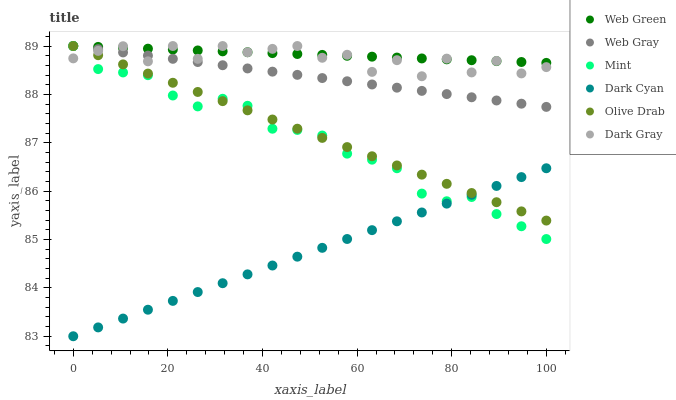Does Dark Cyan have the minimum area under the curve?
Answer yes or no. Yes. Does Web Green have the maximum area under the curve?
Answer yes or no. Yes. Does Dark Gray have the minimum area under the curve?
Answer yes or no. No. Does Dark Gray have the maximum area under the curve?
Answer yes or no. No. Is Web Green the smoothest?
Answer yes or no. Yes. Is Dark Gray the roughest?
Answer yes or no. Yes. Is Dark Gray the smoothest?
Answer yes or no. No. Is Web Green the roughest?
Answer yes or no. No. Does Dark Cyan have the lowest value?
Answer yes or no. Yes. Does Dark Gray have the lowest value?
Answer yes or no. No. Does Olive Drab have the highest value?
Answer yes or no. Yes. Does Dark Cyan have the highest value?
Answer yes or no. No. Is Dark Cyan less than Web Green?
Answer yes or no. Yes. Is Dark Gray greater than Dark Cyan?
Answer yes or no. Yes. Does Dark Cyan intersect Olive Drab?
Answer yes or no. Yes. Is Dark Cyan less than Olive Drab?
Answer yes or no. No. Is Dark Cyan greater than Olive Drab?
Answer yes or no. No. Does Dark Cyan intersect Web Green?
Answer yes or no. No. 